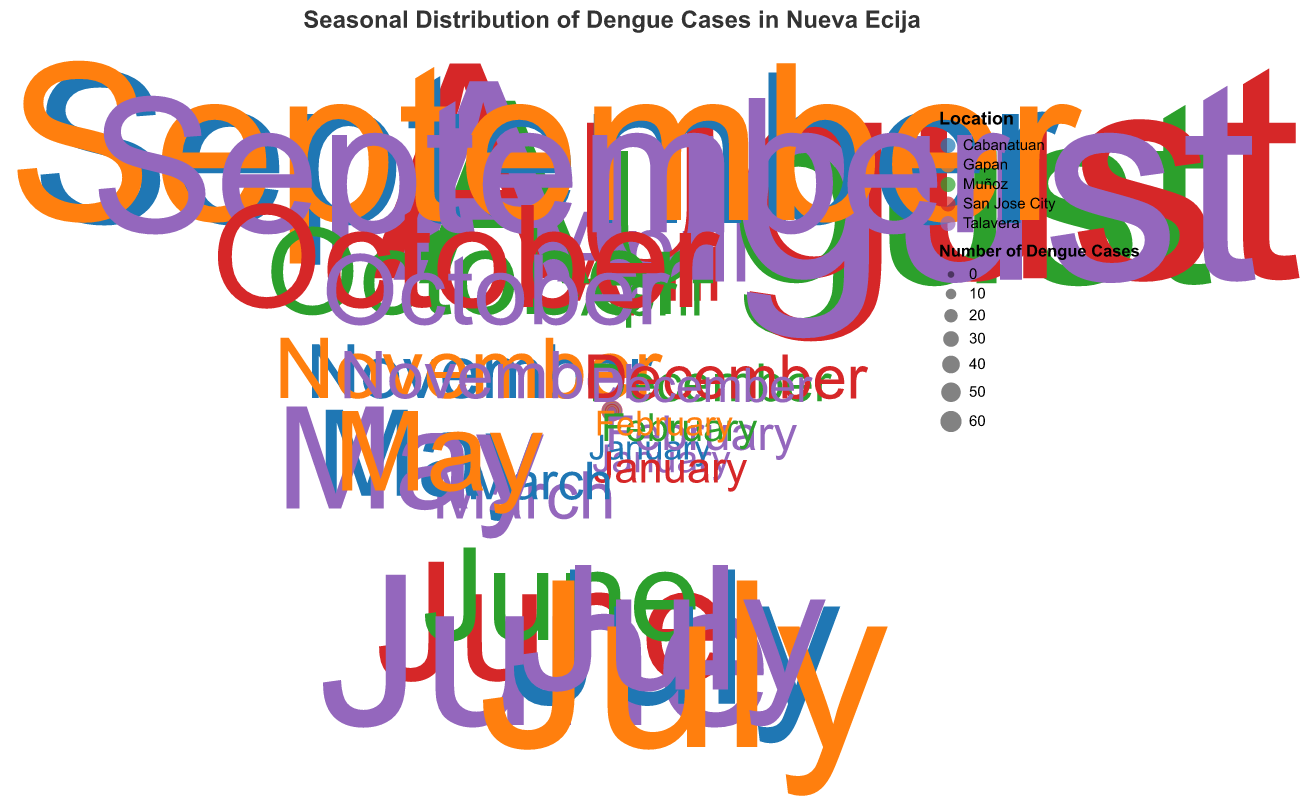Which location had the highest number of dengue cases in August? By observing the graph for the month of August, we can see the size and position of each point. The largest radius indicates the highest count, marked by a specific color. Talavera has the largest number of dengue cases in August.
Answer: Talavera What is the trend of dengue cases in Talavera throughout the year? To understand the trend, follow the position and size of the points for Talavera over the months. The cases in Talavera increase significantly from January to August, peaking in August with 55 cases, and then gradually decrease towards December.
Answer: Increases from January to August, then decreases towards December Which month recorded the highest number of dengue cases in San Jose City? To find this, look for the largest radius point specifically for San Jose City throughout the months. The largest point for San Jose City is in August with 60 cases.
Answer: August How many dengue cases were there in Muñoz in October? Locate the point corresponding to Muñoz in the month of October and read the radius or the size of the point indicated in the legend. The number of dengue cases in Muñoz in October is 20.
Answer: 20 Compare the number of dengue cases between Cabanatuan and Gapan in July. Which one had more cases? Identify the points for Cabanatuan and Gapan in July. Compare their radius sizes or numbers. Gapan had 45 cases while Cabanatuan had 35 cases, so Gapan had more cases in July.
Answer: Gapan During which month did Talavera see its lowest number of dengue cases? By identifying the smallest point or the point with the least radius for Talavera throughout the months, we see that Talavera had its lowest number of dengue cases in January with 2 cases.
Answer: January What is the average number of dengue cases in Talavera during the peak months from June to September? Identify the cases in Talavera from June to September: June (40), July (32), August (55), September (35). Add them up: 40 + 32 + 55 + 35 = 162. Divide by the number of months (4): 162 / 4 = 40.5.
Answer: 40.5 Which location experienced the highest peak of dengue cases in any single month and what was the value? Scan through each month's points and identify which has the largest radius in total. August in San Jose City is the highest peak with 60 cases.
Answer: San Jose City with 60 cases in August How does the number of dengue cases in Talavera in May compare to those in March? Compare the radius size and the numbers for Talavera between March and May. In March Talavera had 8 cases, while in May, it had 25 cases. Therefore, Talavera had significantly more cases in May than in March.
Answer: More cases in May than in March What similarities do you see between the number of cases in Talavera in July and the number of cases in Cabanatuan in September? Compare the corresponding points for Talavera in July and Cabanatuan in September. In both instances, Talavera had 32 cases in July and Cabanatuan had 40 cases in September, which are relatively close in number, both showing high dengue instances.
Answer: Both show high instances in close numbers 